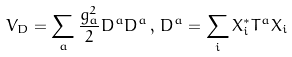Convert formula to latex. <formula><loc_0><loc_0><loc_500><loc_500>V _ { D } = \sum _ { a } \frac { g _ { a } ^ { 2 } } { 2 } D ^ { a } D ^ { a } \, , \, D ^ { a } = \sum _ { i } X _ { i } ^ { * } T ^ { a } X _ { i }</formula> 